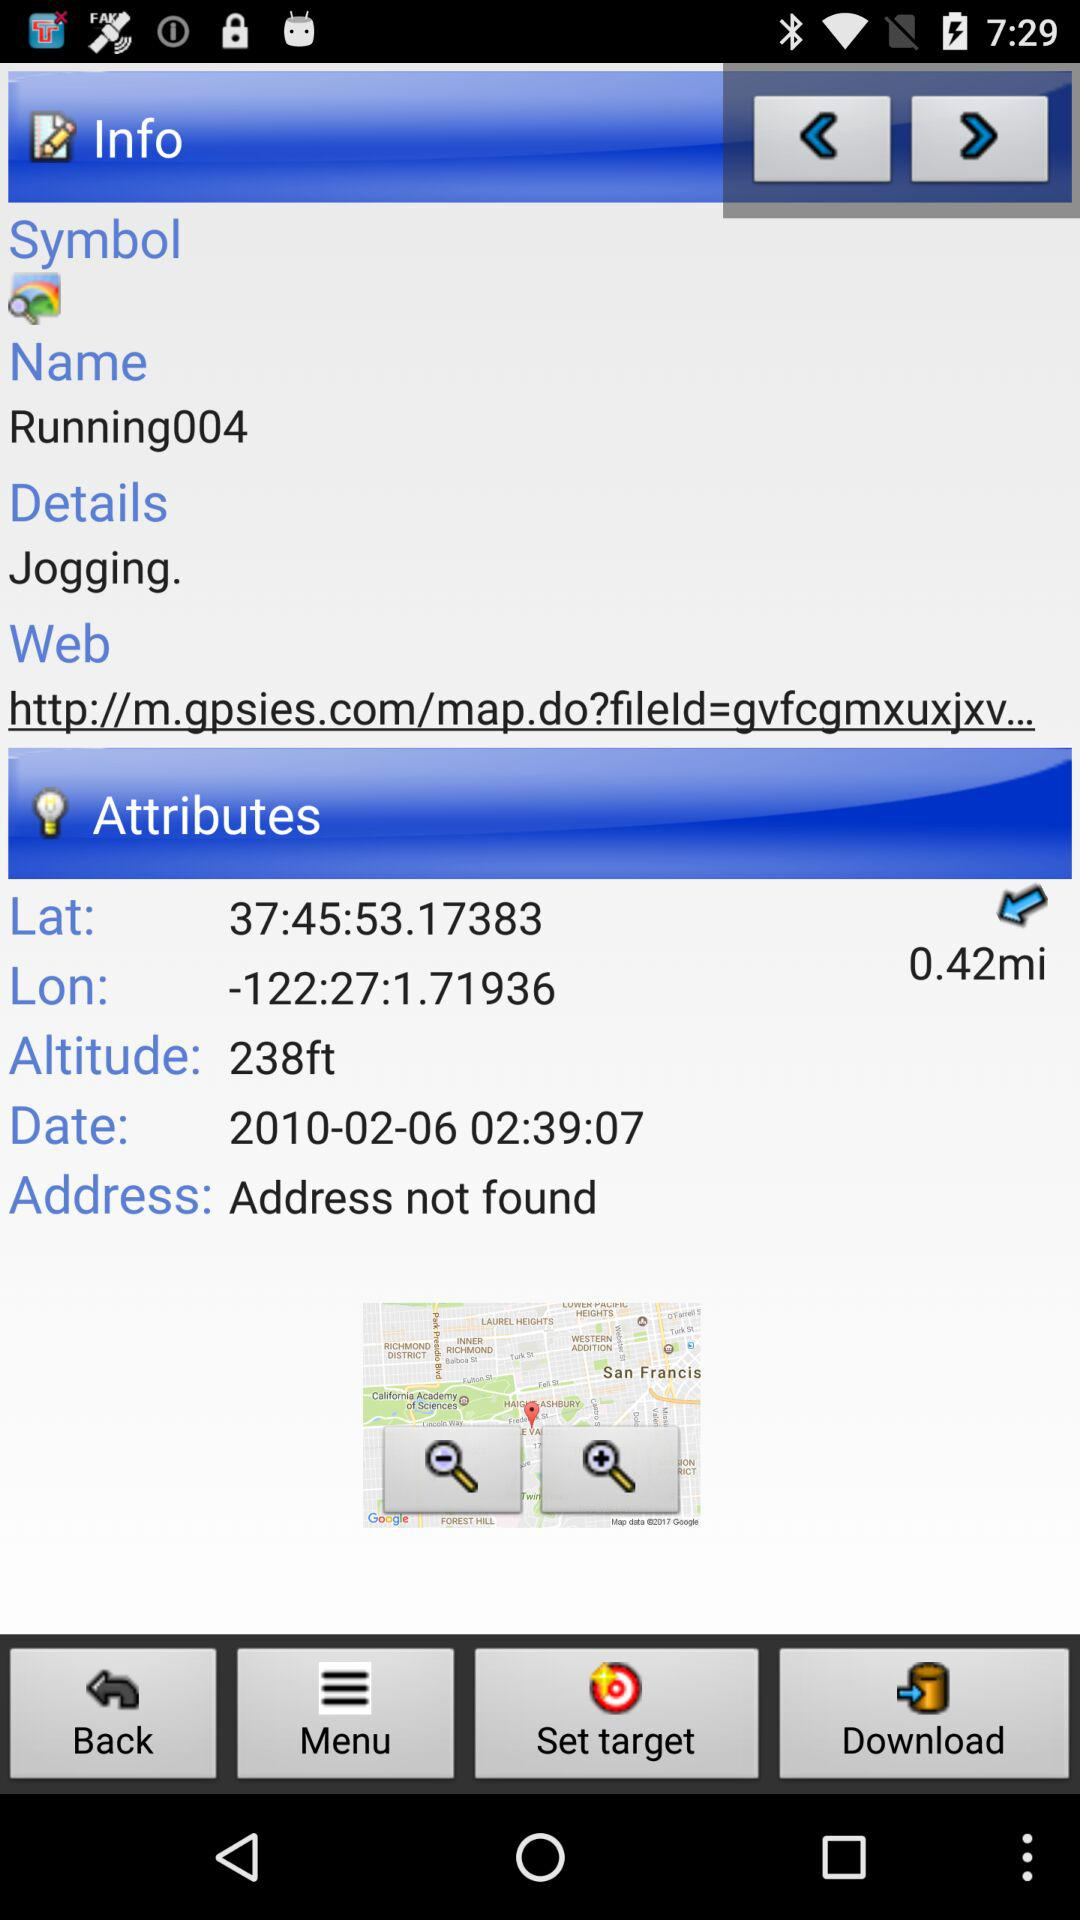What's the username? The username is "Running004". 